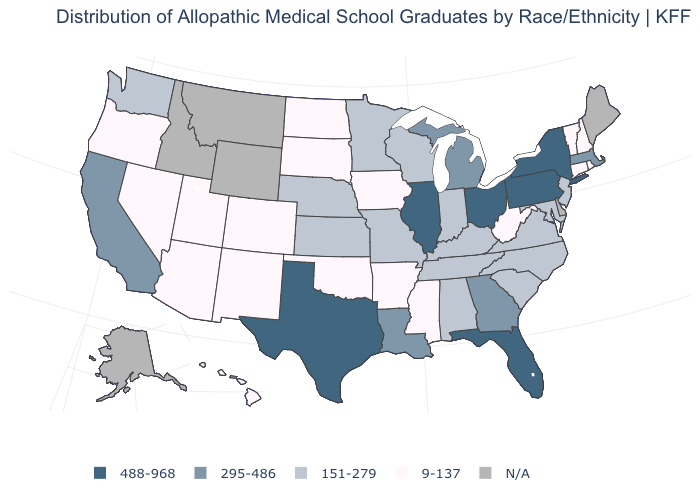What is the value of New Hampshire?
Quick response, please. 9-137. What is the value of Kentucky?
Keep it brief. 151-279. Which states hav the highest value in the West?
Write a very short answer. California. What is the value of Georgia?
Keep it brief. 295-486. Among the states that border Missouri , which have the lowest value?
Quick response, please. Arkansas, Iowa, Oklahoma. Does the map have missing data?
Give a very brief answer. Yes. What is the value of Kentucky?
Be succinct. 151-279. Name the states that have a value in the range 151-279?
Write a very short answer. Alabama, Indiana, Kansas, Kentucky, Maryland, Minnesota, Missouri, Nebraska, New Jersey, North Carolina, South Carolina, Tennessee, Virginia, Washington, Wisconsin. What is the value of West Virginia?
Keep it brief. 9-137. Is the legend a continuous bar?
Write a very short answer. No. Name the states that have a value in the range 9-137?
Concise answer only. Arizona, Arkansas, Colorado, Connecticut, Hawaii, Iowa, Mississippi, Nevada, New Hampshire, New Mexico, North Dakota, Oklahoma, Oregon, Rhode Island, South Dakota, Utah, Vermont, West Virginia. Which states have the highest value in the USA?
Answer briefly. Florida, Illinois, New York, Ohio, Pennsylvania, Texas. Among the states that border Montana , which have the lowest value?
Short answer required. North Dakota, South Dakota. Name the states that have a value in the range N/A?
Write a very short answer. Alaska, Delaware, Idaho, Maine, Montana, Wyoming. 